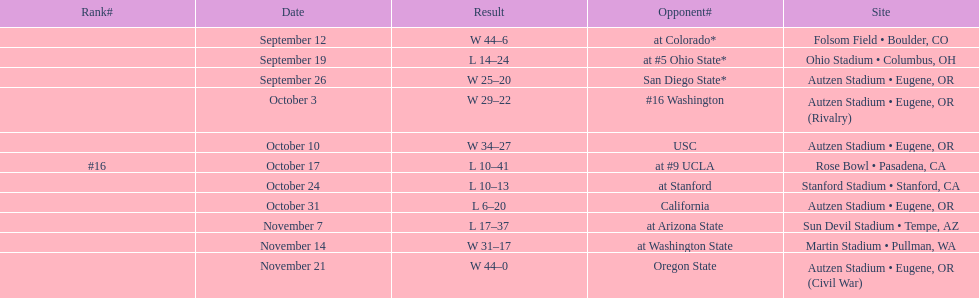How many wins are listed for the season? 6. 